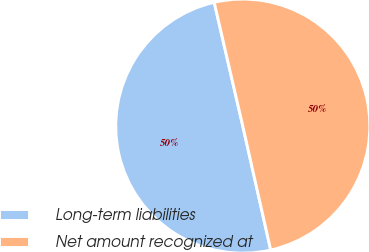<chart> <loc_0><loc_0><loc_500><loc_500><pie_chart><fcel>Long-term liabilities<fcel>Net amount recognized at<nl><fcel>49.91%<fcel>50.09%<nl></chart> 